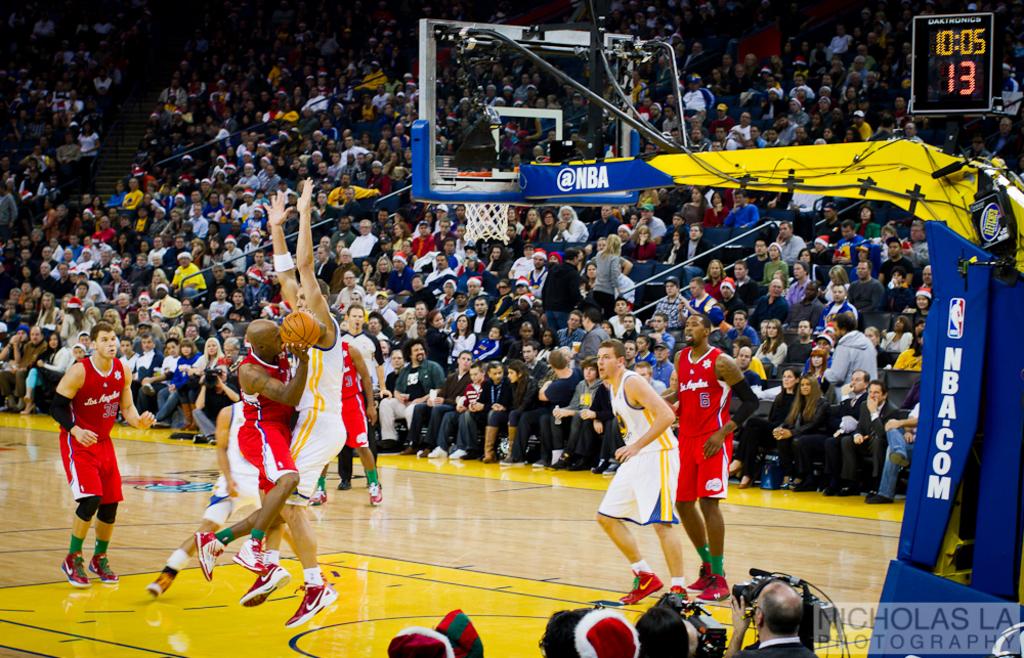What is the url on the goal post?
Provide a short and direct response. Nba.com. How much time is left on the shot clock?
Give a very brief answer. 10:05. 